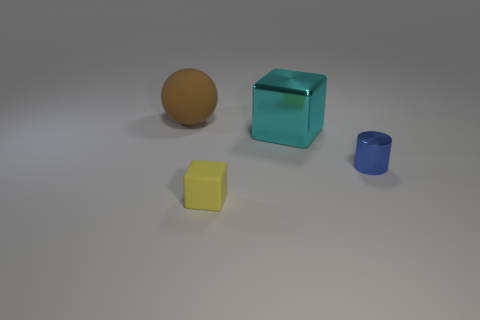Is there another small cylinder that has the same color as the tiny cylinder?
Your response must be concise. No. What number of other objects are there of the same shape as the blue object?
Ensure brevity in your answer.  0. The big object that is on the left side of the yellow matte thing has what shape?
Keep it short and to the point. Sphere. There is a tiny yellow matte thing; is it the same shape as the object that is to the right of the large metal thing?
Provide a succinct answer. No. How big is the thing that is on the left side of the big cyan metal object and behind the tiny metallic object?
Your response must be concise. Large. What is the color of the object that is both in front of the big cyan shiny block and left of the big cyan metal block?
Provide a short and direct response. Yellow. Is there anything else that has the same material as the large cyan object?
Provide a succinct answer. Yes. Are there fewer small rubber things that are on the left side of the yellow thing than tiny matte objects behind the tiny shiny cylinder?
Provide a succinct answer. No. Is there anything else that has the same color as the cylinder?
Offer a very short reply. No. What is the shape of the yellow matte thing?
Keep it short and to the point. Cube. 